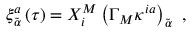Convert formula to latex. <formula><loc_0><loc_0><loc_500><loc_500>\xi _ { \tilde { \alpha } } ^ { a } \left ( \tau \right ) = X _ { i } ^ { M } \left ( \Gamma _ { M } \kappa ^ { i a } \right ) _ { \tilde { \alpha } } \, ,</formula> 